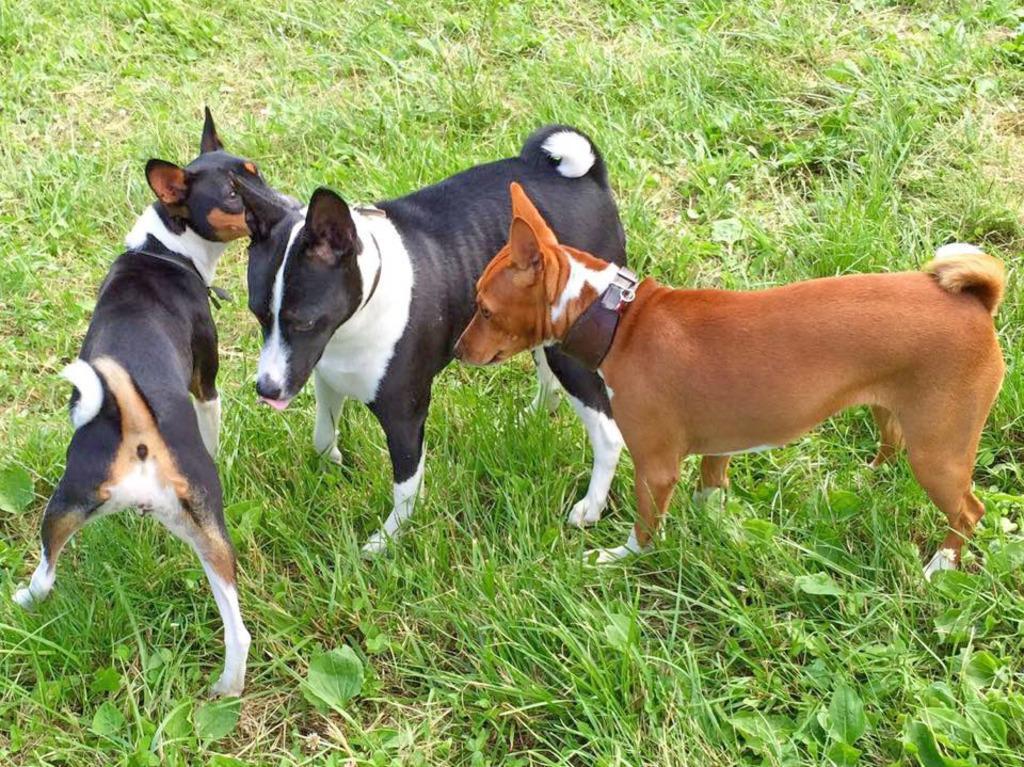Please provide a concise description of this image. In the center of the image there are dogs. At the bottom of the image there is grass. 